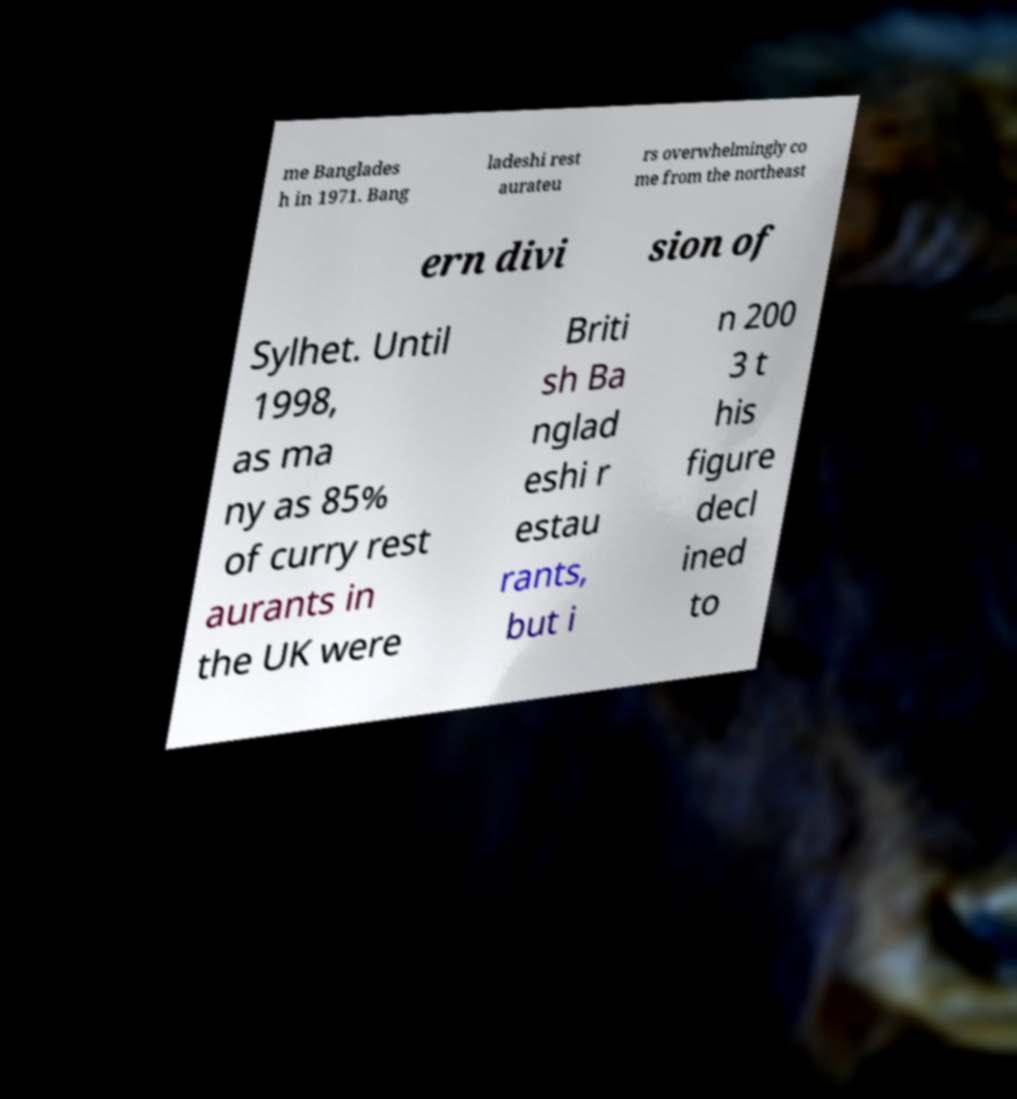There's text embedded in this image that I need extracted. Can you transcribe it verbatim? me Banglades h in 1971. Bang ladeshi rest aurateu rs overwhelmingly co me from the northeast ern divi sion of Sylhet. Until 1998, as ma ny as 85% of curry rest aurants in the UK were Briti sh Ba nglad eshi r estau rants, but i n 200 3 t his figure decl ined to 